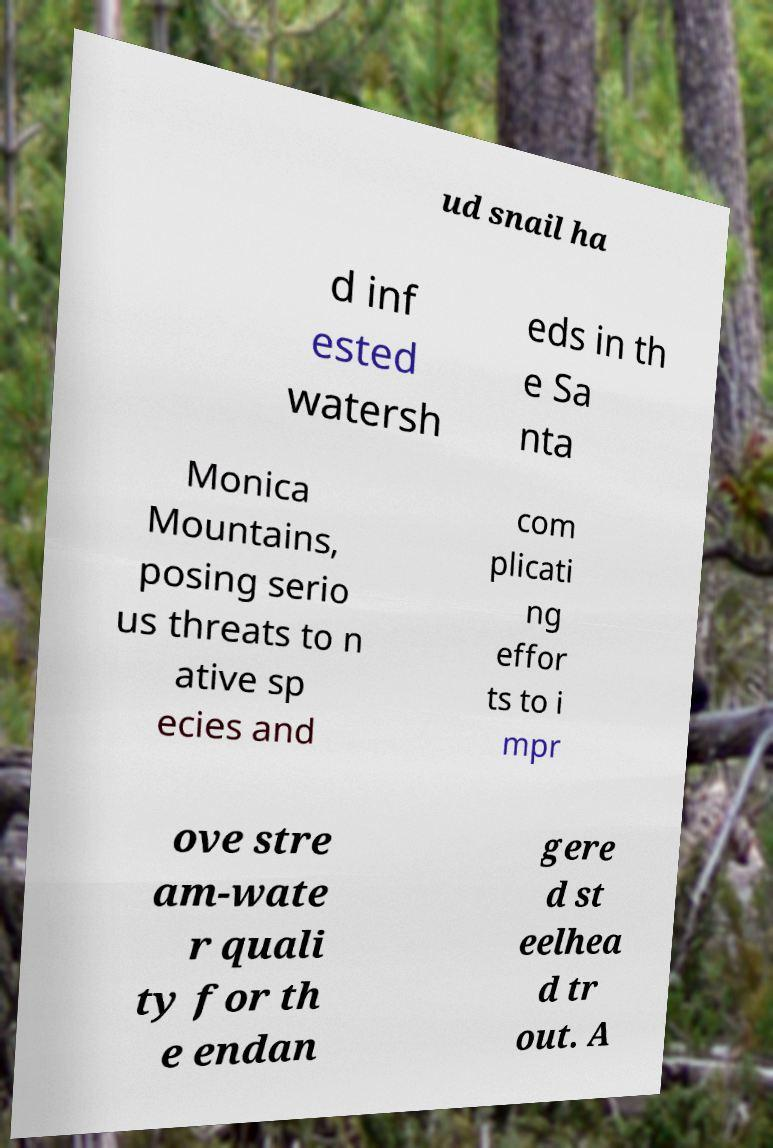Please read and relay the text visible in this image. What does it say? ud snail ha d inf ested watersh eds in th e Sa nta Monica Mountains, posing serio us threats to n ative sp ecies and com plicati ng effor ts to i mpr ove stre am-wate r quali ty for th e endan gere d st eelhea d tr out. A 